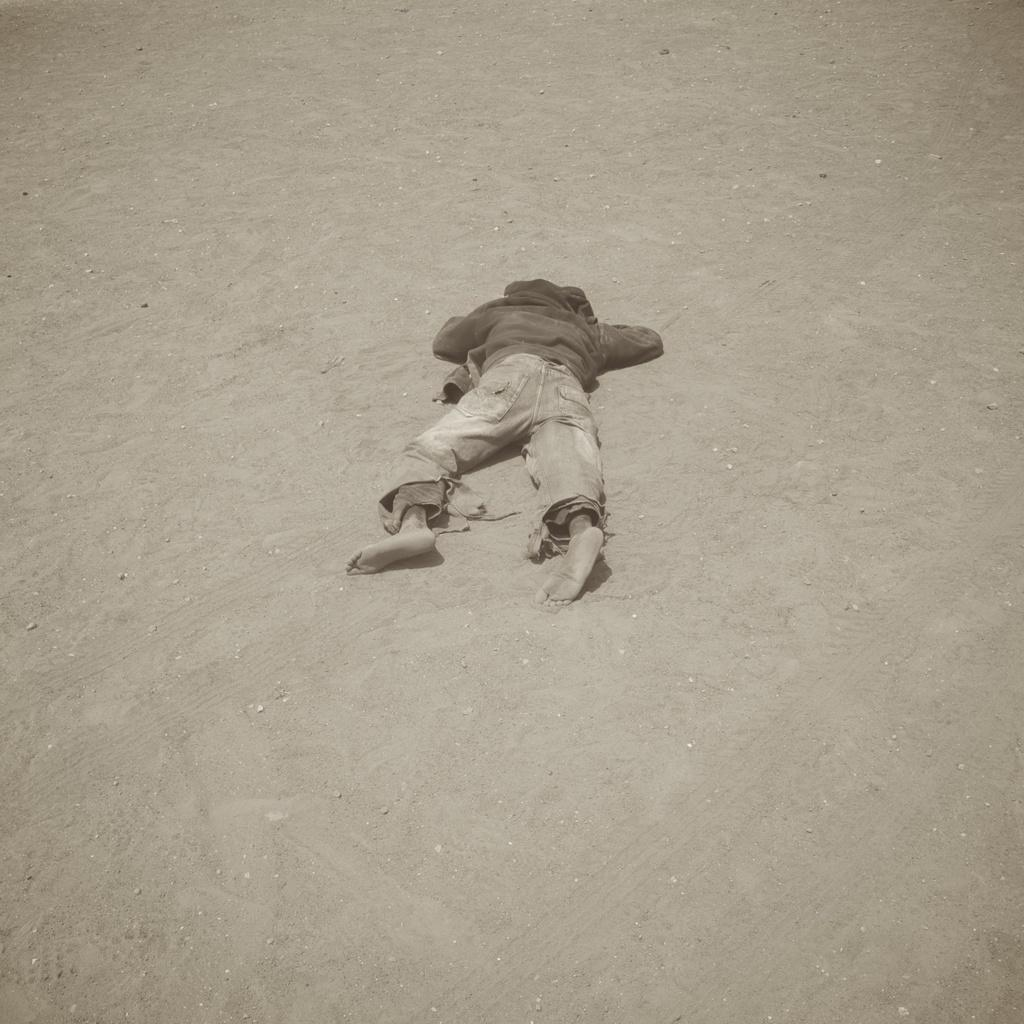What is the main subject of the image? There is a person in the image. What is the person doing in the image? The person is laying on the sand ground. What type of jelly can be seen in the image? There is no jelly present in the image. What kind of machine is being used by the person in the image? There is no machine present in the image; the person is simply laying on the sand ground. 